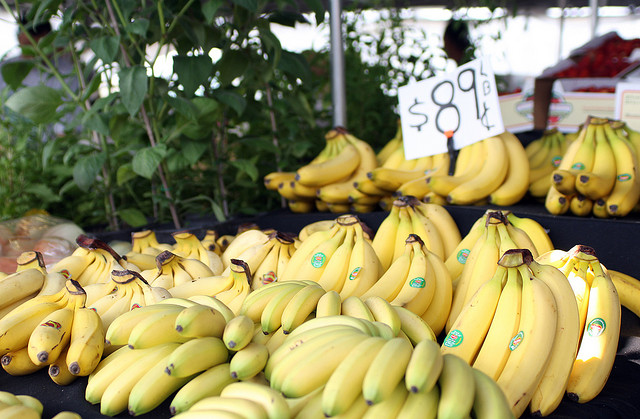Identify the text displayed in this image. 89 